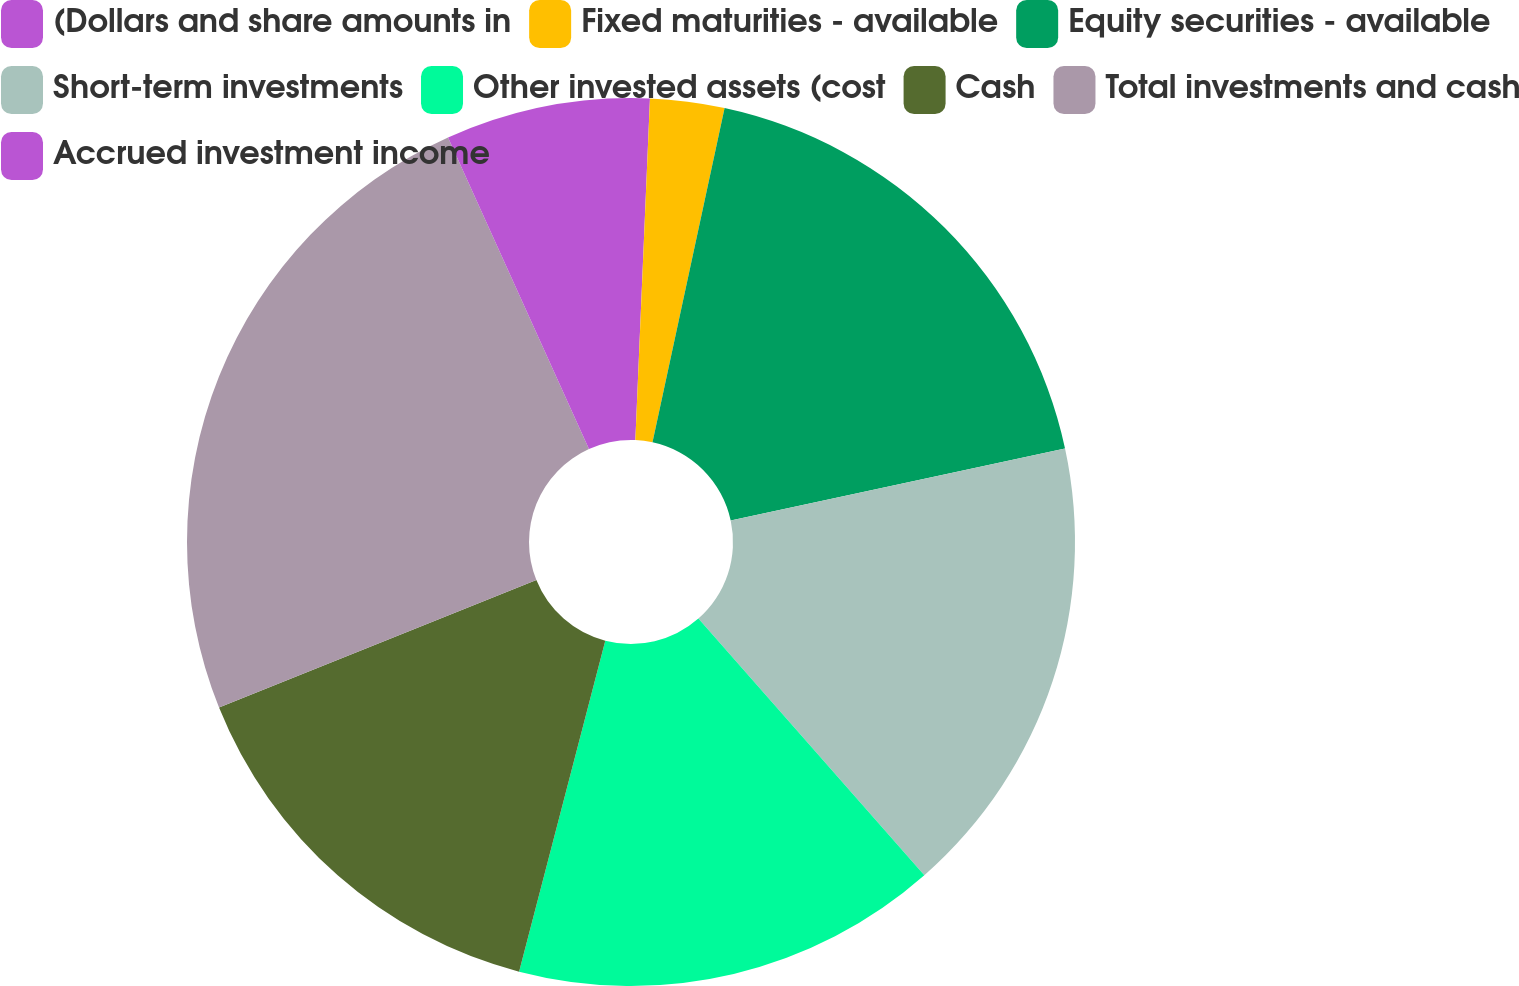Convert chart to OTSL. <chart><loc_0><loc_0><loc_500><loc_500><pie_chart><fcel>(Dollars and share amounts in<fcel>Fixed maturities - available<fcel>Equity securities - available<fcel>Short-term investments<fcel>Other invested assets (cost<fcel>Cash<fcel>Total investments and cash<fcel>Accrued investment income<nl><fcel>0.68%<fcel>2.7%<fcel>18.24%<fcel>16.89%<fcel>15.54%<fcel>14.86%<fcel>24.32%<fcel>6.76%<nl></chart> 